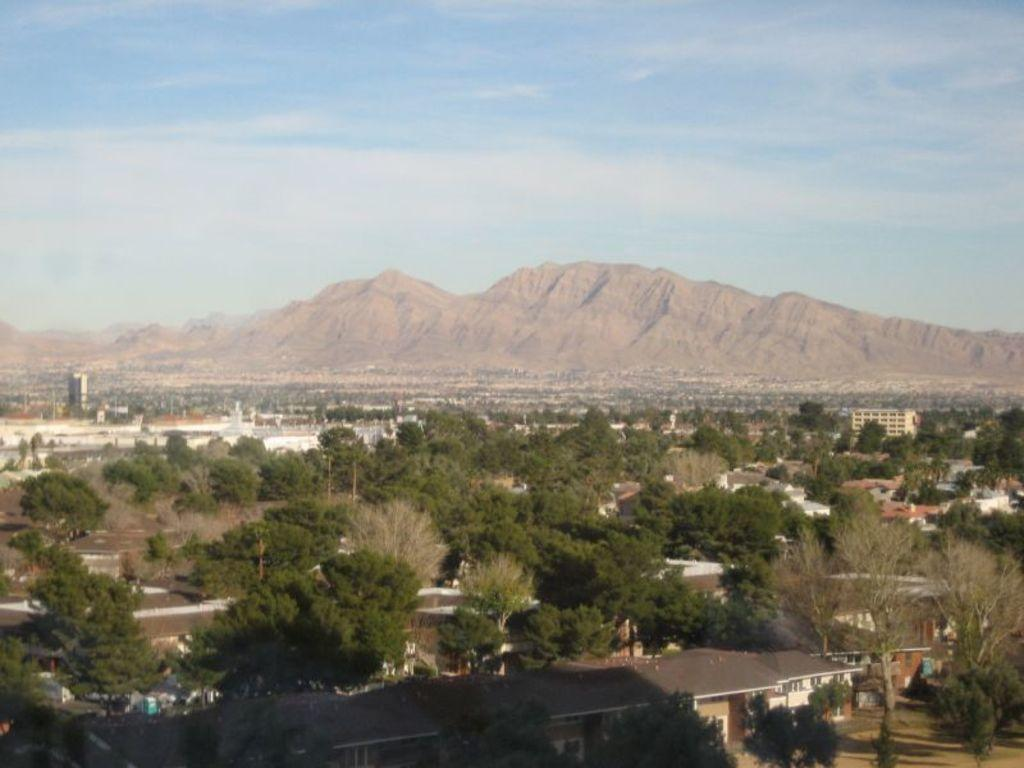Where was the image taken? The image was taken outside. What can be seen in the foreground of the image? There are trees and buildings in the foreground of the image. What type of location is depicted in the image? The image depicts a city. What natural features can be seen in the image? There are mountains visible in the image. What is visible in the sky in the image? The sky is visible in the image, and clouds are present. How many trains can be seen passing through downtown in the image? There are no trains or downtown area visible in the image. 